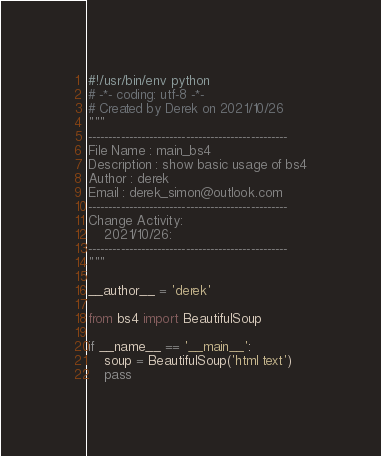Convert code to text. <code><loc_0><loc_0><loc_500><loc_500><_Python_>#!/usr/bin/env python
# -*- coding: utf-8 -*-
# Created by Derek on 2021/10/26
"""
-------------------------------------------------
File Name : main_bs4 
Description : show basic usage of bs4
Author : derek
Email : derek_simon@outlook.com
-------------------------------------------------
Change Activity:
    2021/10/26:
-------------------------------------------------
"""

__author__ = 'derek'

from bs4 import BeautifulSoup

if __name__ == '__main__':
    soup = BeautifulSoup('html text')
    pass
</code> 